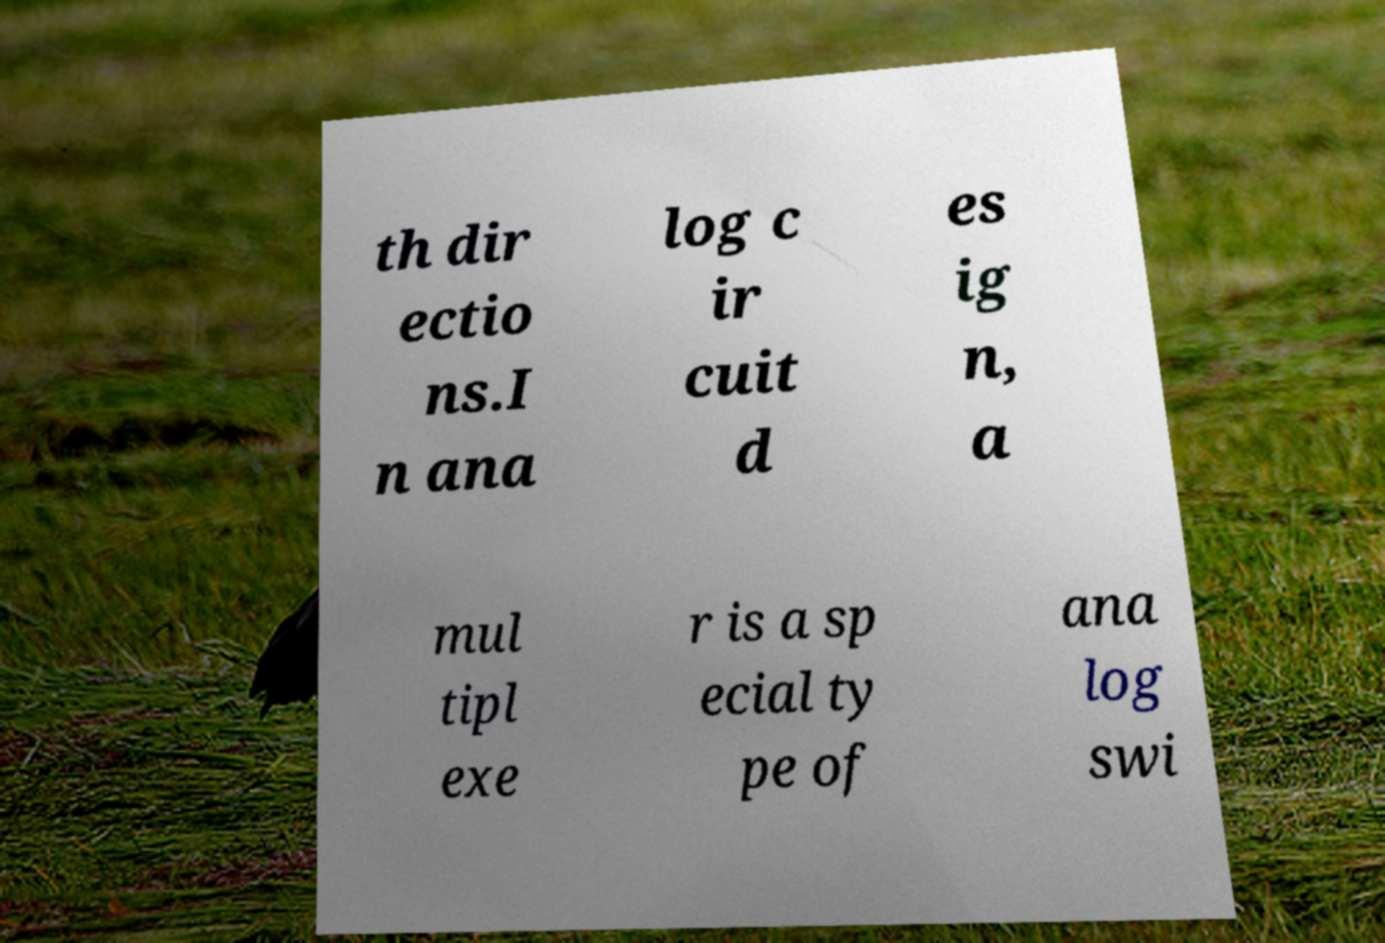For documentation purposes, I need the text within this image transcribed. Could you provide that? th dir ectio ns.I n ana log c ir cuit d es ig n, a mul tipl exe r is a sp ecial ty pe of ana log swi 